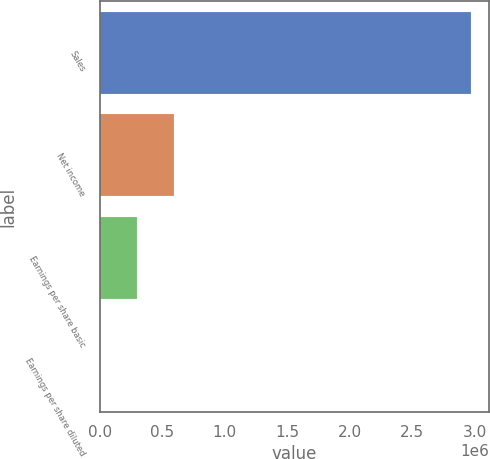Convert chart. <chart><loc_0><loc_0><loc_500><loc_500><bar_chart><fcel>Sales<fcel>Net income<fcel>Earnings per share basic<fcel>Earnings per share diluted<nl><fcel>2.96742e+06<fcel>593487<fcel>296746<fcel>4.62<nl></chart> 